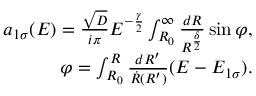<formula> <loc_0><loc_0><loc_500><loc_500>\begin{array} { r } { a _ { 1 \sigma } ( E ) = \frac { \sqrt { D } } { i \pi } E ^ { - \frac { \gamma } { 2 } } \int _ { R _ { 0 } } ^ { \infty } \frac { d R } { R ^ { \frac { \delta } { 2 } } } \sin \varphi , } \\ { \varphi = \int _ { R _ { 0 } } ^ { R } \frac { d R ^ { \prime } } { \dot { R } ( R ^ { \prime } ) } ( E - E _ { 1 \sigma } ) . } \end{array}</formula> 